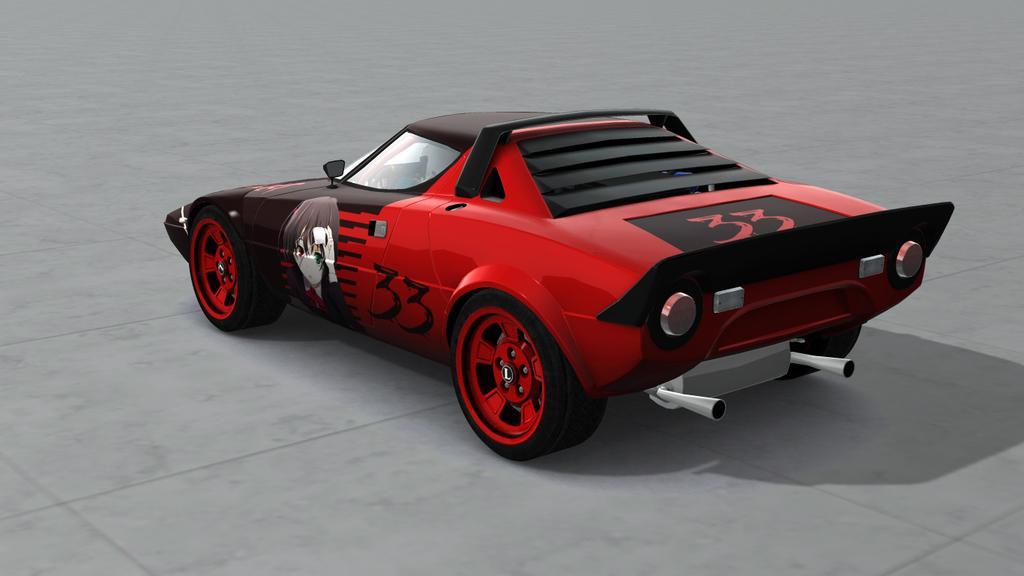In one or two sentences, can you explain what this image depicts? In this image we can see red color car which is on road. 